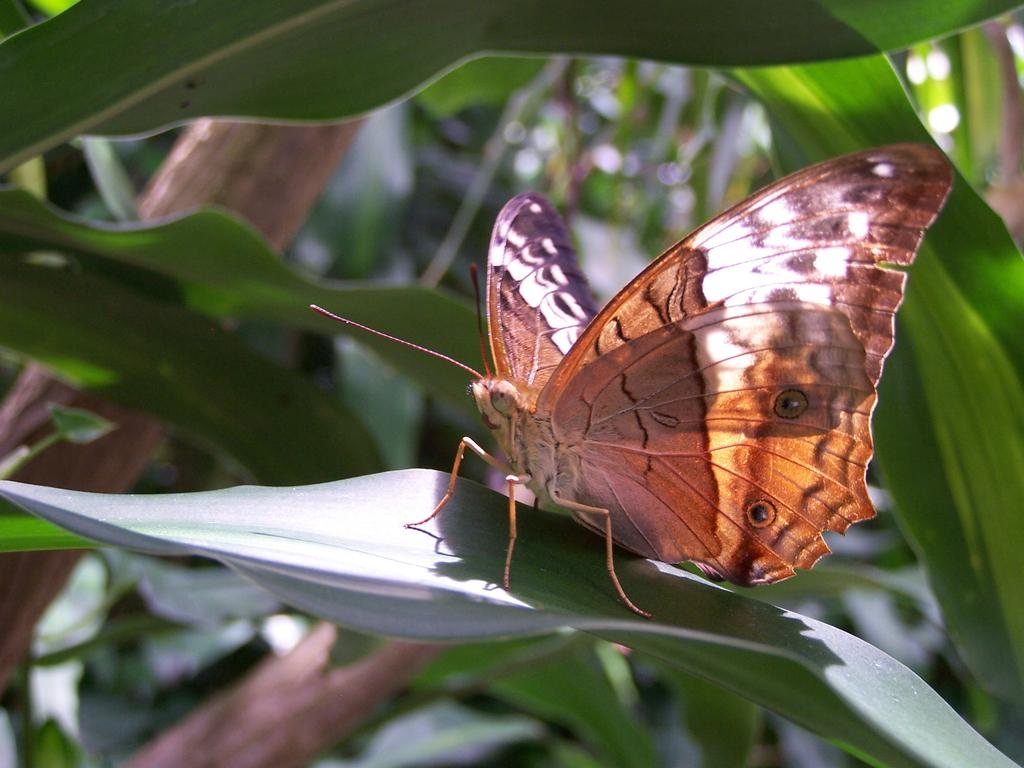What is present in the image? There is a butterfly in the image. Where is the butterfly located? The butterfly is laying on the leaf of a tree. What type of beetle can be seen with fangs in the image? There is no beetle or fangs present in the image; it features a butterfly on a leaf. Can you tell me how many times the butterfly dives into the ocean in the image? There is no ocean present in the image, and therefore the butterfly cannot dive into it. 